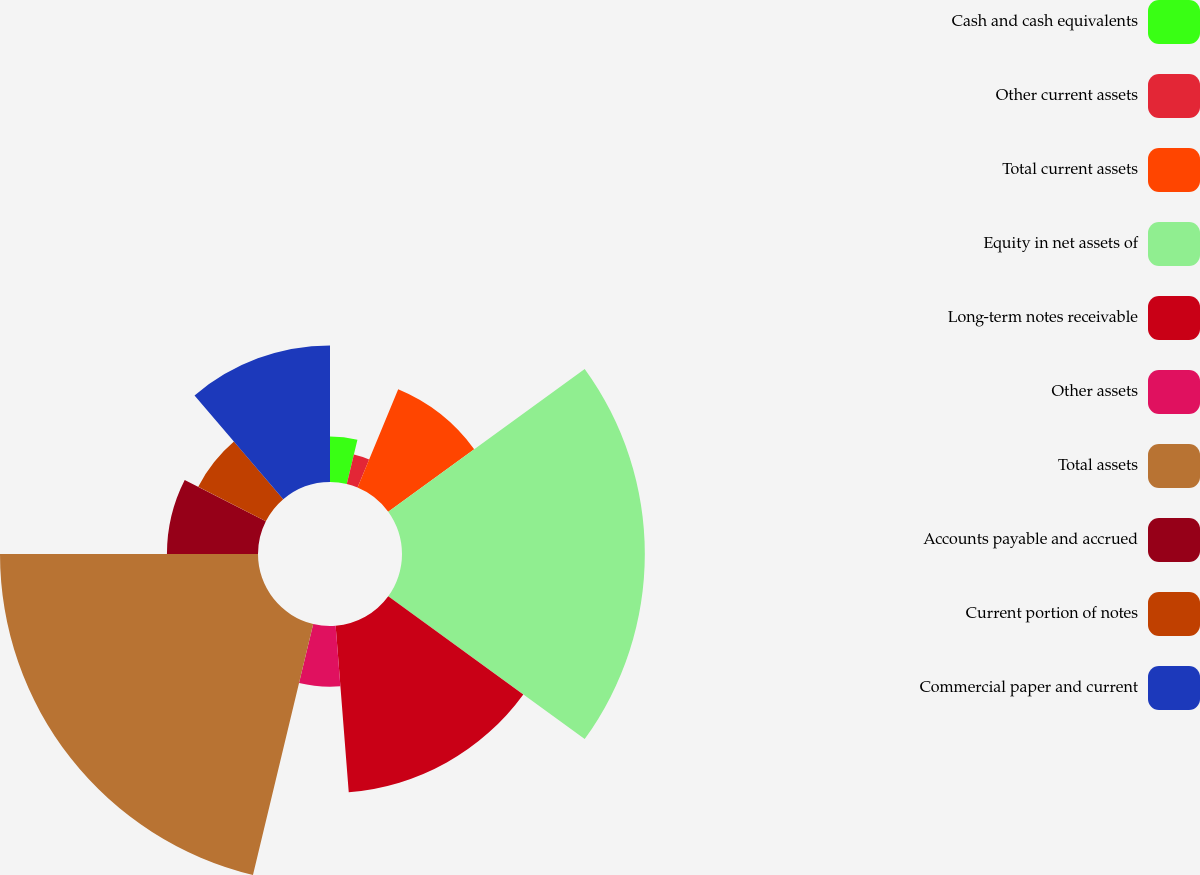Convert chart. <chart><loc_0><loc_0><loc_500><loc_500><pie_chart><fcel>Cash and cash equivalents<fcel>Other current assets<fcel>Total current assets<fcel>Equity in net assets of<fcel>Long-term notes receivable<fcel>Other assets<fcel>Total assets<fcel>Accounts payable and accrued<fcel>Current portion of notes<fcel>Commercial paper and current<nl><fcel>3.75%<fcel>2.5%<fcel>8.75%<fcel>20.0%<fcel>13.75%<fcel>5.0%<fcel>21.25%<fcel>7.5%<fcel>6.25%<fcel>11.25%<nl></chart> 